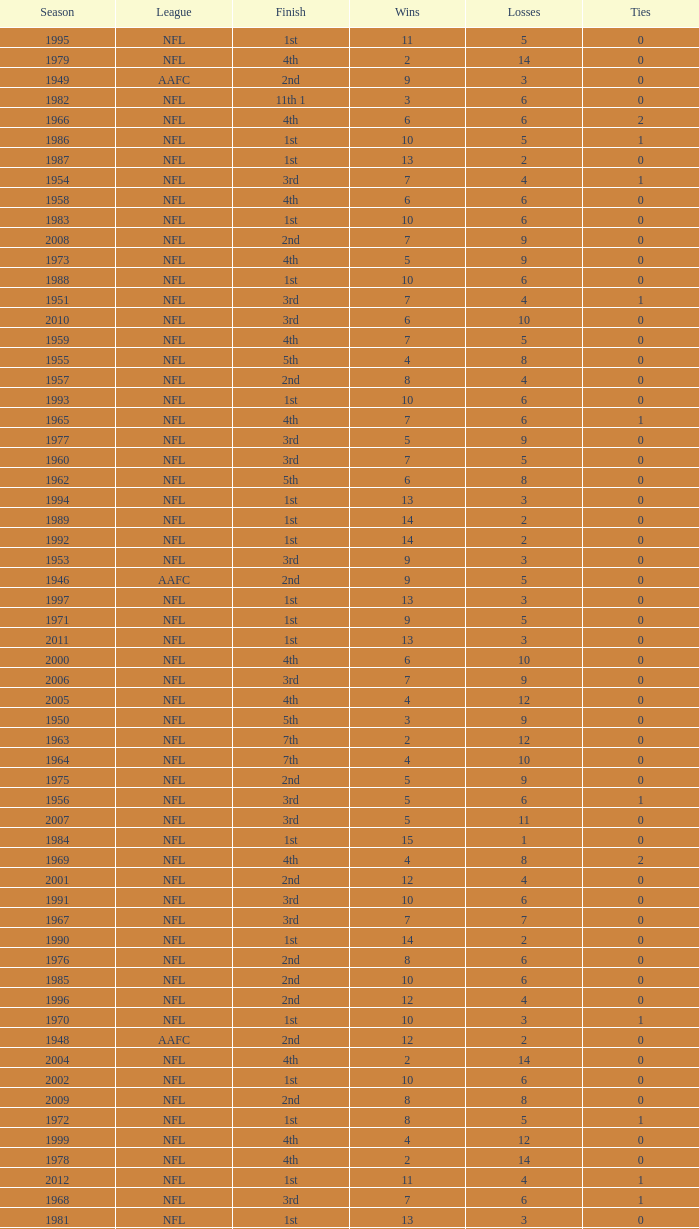What is the losses in the NFL in the 2011 season with less than 13 wins? None. 